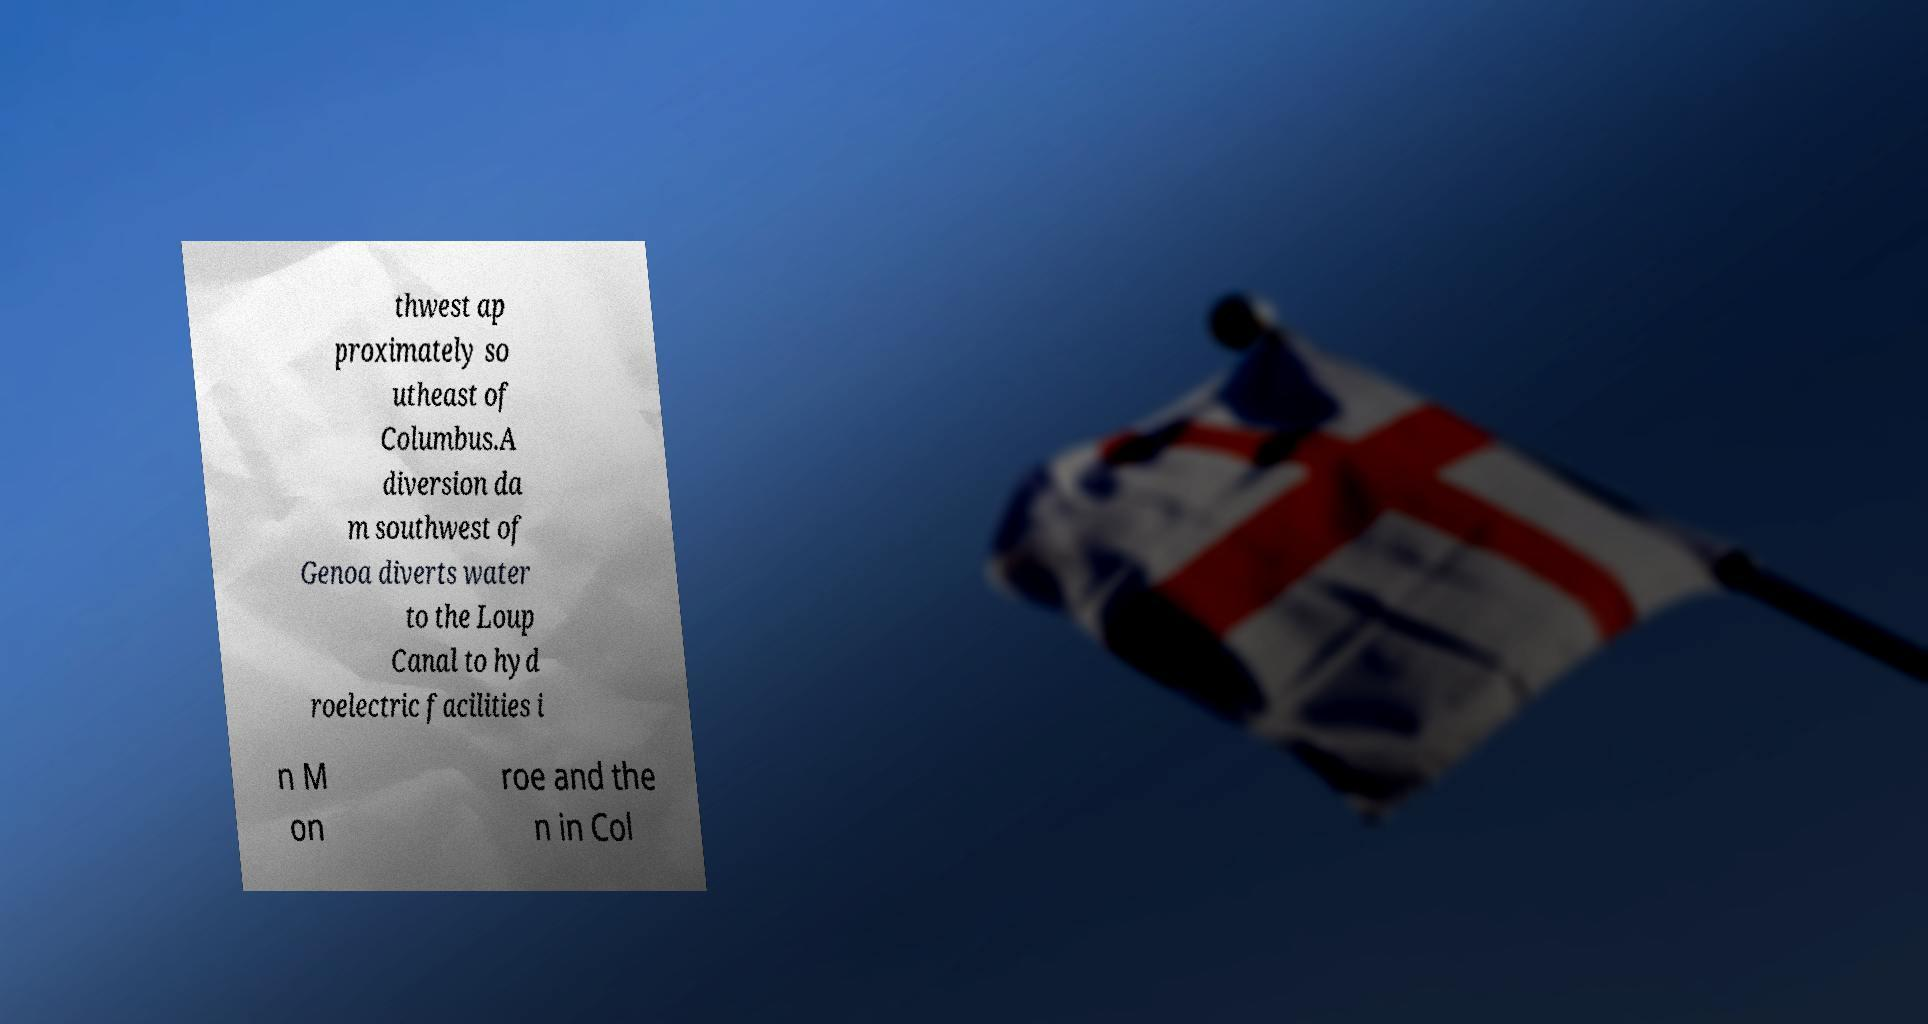What messages or text are displayed in this image? I need them in a readable, typed format. thwest ap proximately so utheast of Columbus.A diversion da m southwest of Genoa diverts water to the Loup Canal to hyd roelectric facilities i n M on roe and the n in Col 